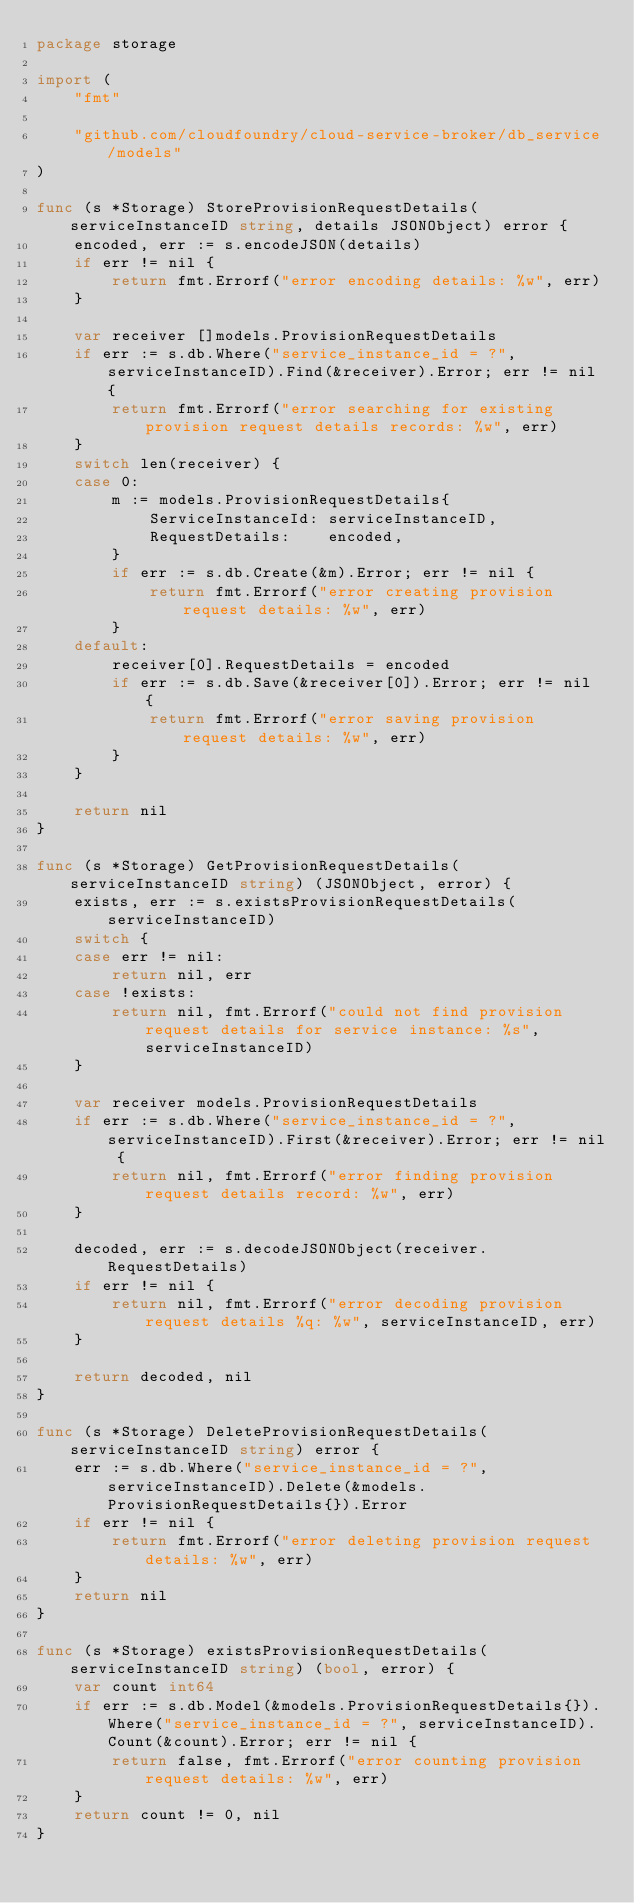Convert code to text. <code><loc_0><loc_0><loc_500><loc_500><_Go_>package storage

import (
	"fmt"

	"github.com/cloudfoundry/cloud-service-broker/db_service/models"
)

func (s *Storage) StoreProvisionRequestDetails(serviceInstanceID string, details JSONObject) error {
	encoded, err := s.encodeJSON(details)
	if err != nil {
		return fmt.Errorf("error encoding details: %w", err)
	}

	var receiver []models.ProvisionRequestDetails
	if err := s.db.Where("service_instance_id = ?", serviceInstanceID).Find(&receiver).Error; err != nil {
		return fmt.Errorf("error searching for existing provision request details records: %w", err)
	}
	switch len(receiver) {
	case 0:
		m := models.ProvisionRequestDetails{
			ServiceInstanceId: serviceInstanceID,
			RequestDetails:    encoded,
		}
		if err := s.db.Create(&m).Error; err != nil {
			return fmt.Errorf("error creating provision request details: %w", err)
		}
	default:
		receiver[0].RequestDetails = encoded
		if err := s.db.Save(&receiver[0]).Error; err != nil {
			return fmt.Errorf("error saving provision request details: %w", err)
		}
	}

	return nil
}

func (s *Storage) GetProvisionRequestDetails(serviceInstanceID string) (JSONObject, error) {
	exists, err := s.existsProvisionRequestDetails(serviceInstanceID)
	switch {
	case err != nil:
		return nil, err
	case !exists:
		return nil, fmt.Errorf("could not find provision request details for service instance: %s", serviceInstanceID)
	}

	var receiver models.ProvisionRequestDetails
	if err := s.db.Where("service_instance_id = ?", serviceInstanceID).First(&receiver).Error; err != nil {
		return nil, fmt.Errorf("error finding provision request details record: %w", err)
	}

	decoded, err := s.decodeJSONObject(receiver.RequestDetails)
	if err != nil {
		return nil, fmt.Errorf("error decoding provision request details %q: %w", serviceInstanceID, err)
	}

	return decoded, nil
}

func (s *Storage) DeleteProvisionRequestDetails(serviceInstanceID string) error {
	err := s.db.Where("service_instance_id = ?", serviceInstanceID).Delete(&models.ProvisionRequestDetails{}).Error
	if err != nil {
		return fmt.Errorf("error deleting provision request details: %w", err)
	}
	return nil
}

func (s *Storage) existsProvisionRequestDetails(serviceInstanceID string) (bool, error) {
	var count int64
	if err := s.db.Model(&models.ProvisionRequestDetails{}).Where("service_instance_id = ?", serviceInstanceID).Count(&count).Error; err != nil {
		return false, fmt.Errorf("error counting provision request details: %w", err)
	}
	return count != 0, nil
}
</code> 